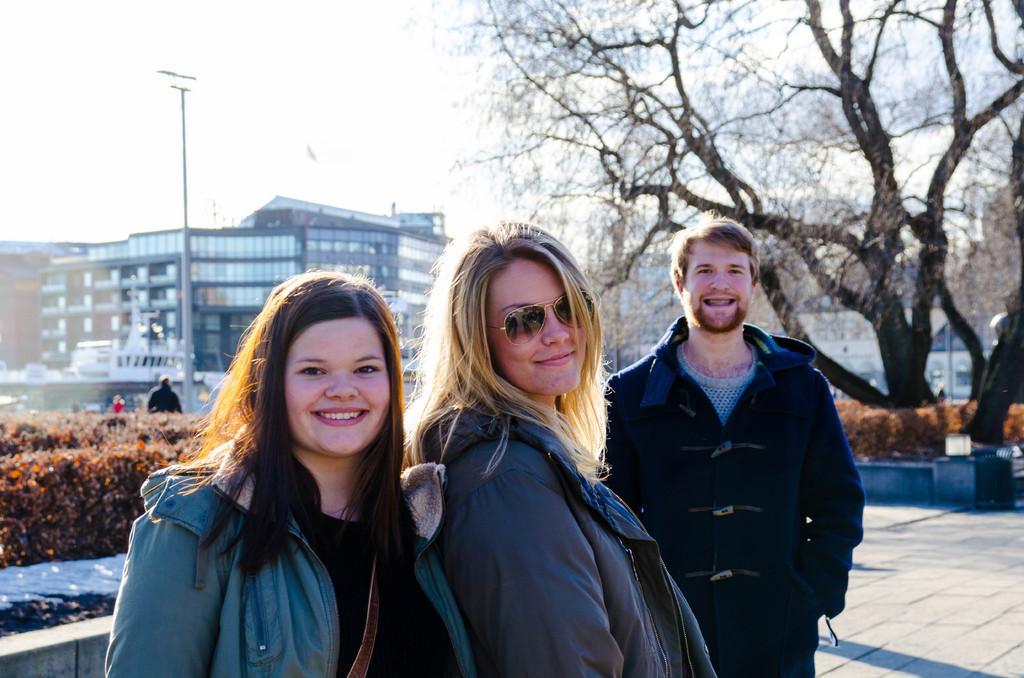Could you give a brief overview of what you see in this image? This picture describes about group f people, in the middle of the given image we can see two women and a man, they are smiling, in the background we can find few shrubs, trees, poles and buildings. 